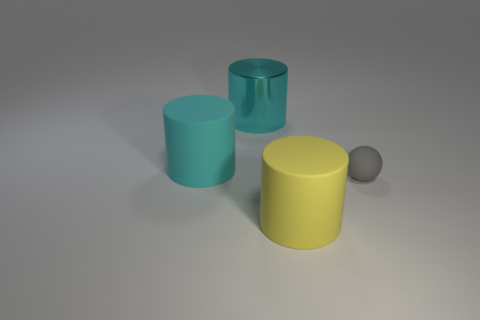Are these objects arranged in any particular pattern? The objects are arranged loosely from left to right, with no precise pattern. They are spaced out on a flat surface and appear to be randomly placed. 